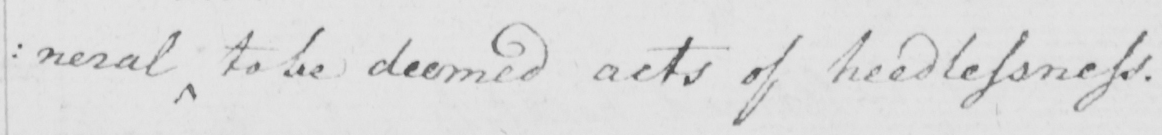Can you tell me what this handwritten text says? : neral to be deemed acts of needlessness . 